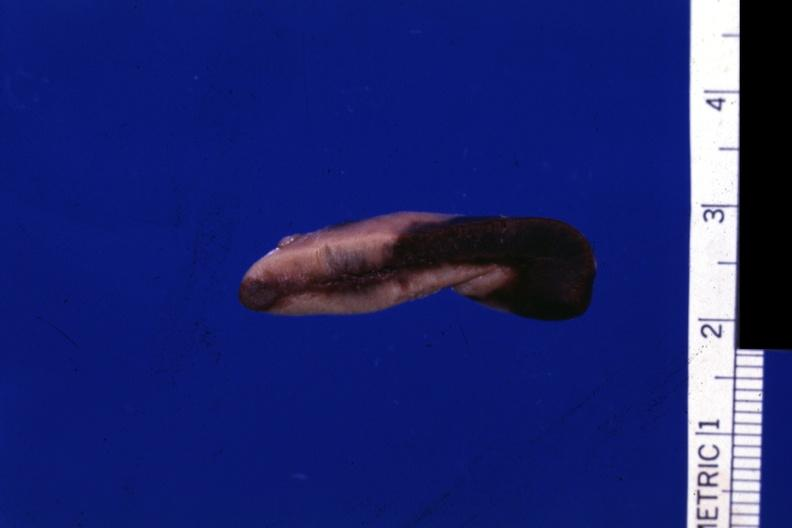what is present?
Answer the question using a single word or phrase. Adrenal 